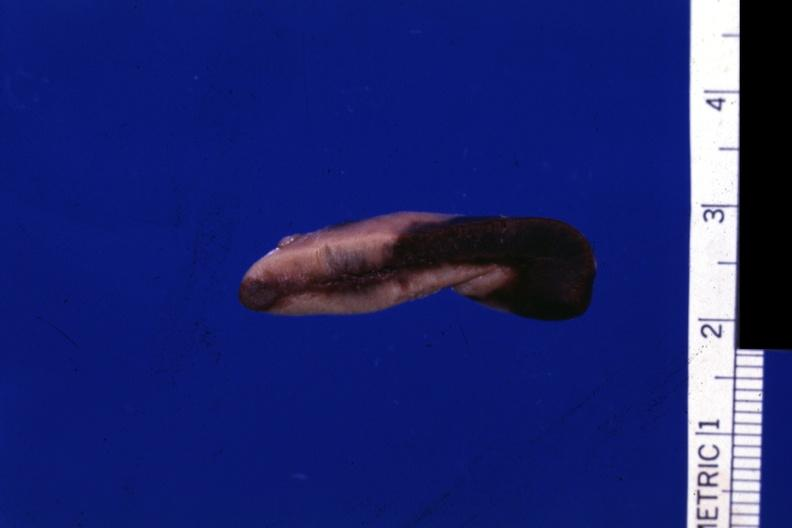what is present?
Answer the question using a single word or phrase. Adrenal 